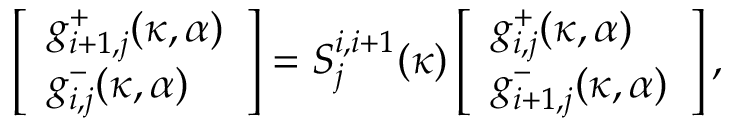Convert formula to latex. <formula><loc_0><loc_0><loc_500><loc_500>\left [ \begin{array} { l } { g _ { i + 1 , j } ^ { + } ( \kappa , \alpha ) } \\ { g _ { i , j } ^ { - } ( \kappa , \alpha ) } \end{array} \right ] = S _ { j } ^ { i , i + 1 } ( \kappa ) \left [ \begin{array} { l } { g _ { i , j } ^ { + } ( \kappa , \alpha ) } \\ { g _ { i + 1 , j } ^ { - } ( \kappa , \alpha ) } \end{array} \right ] ,</formula> 